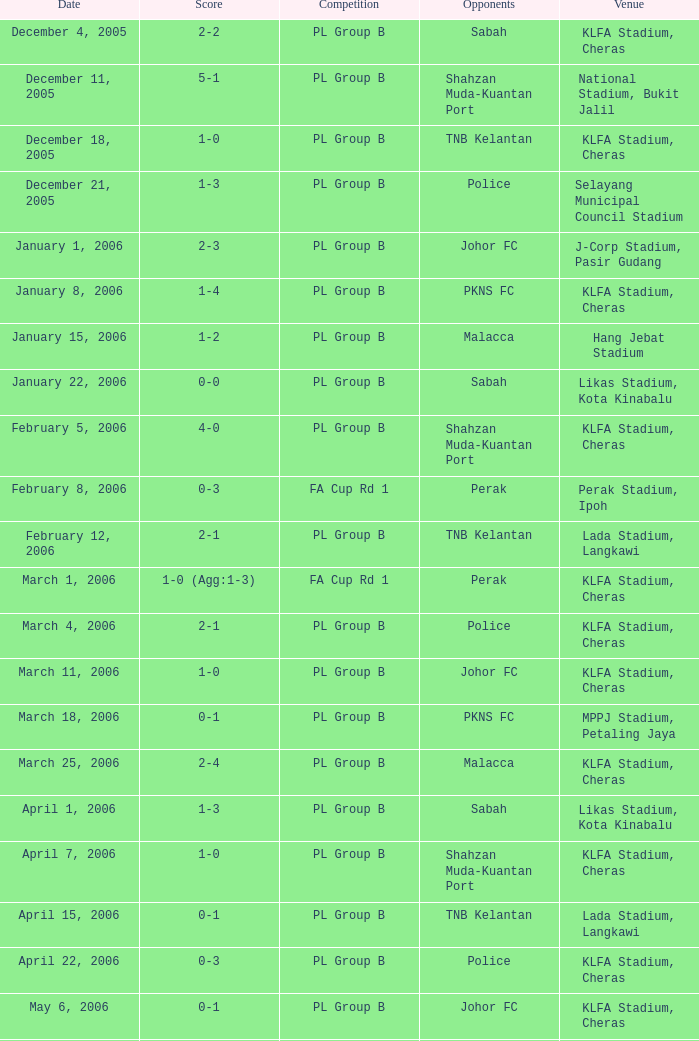Parse the table in full. {'header': ['Date', 'Score', 'Competition', 'Opponents', 'Venue'], 'rows': [['December 4, 2005', '2-2', 'PL Group B', 'Sabah', 'KLFA Stadium, Cheras'], ['December 11, 2005', '5-1', 'PL Group B', 'Shahzan Muda-Kuantan Port', 'National Stadium, Bukit Jalil'], ['December 18, 2005', '1-0', 'PL Group B', 'TNB Kelantan', 'KLFA Stadium, Cheras'], ['December 21, 2005', '1-3', 'PL Group B', 'Police', 'Selayang Municipal Council Stadium'], ['January 1, 2006', '2-3', 'PL Group B', 'Johor FC', 'J-Corp Stadium, Pasir Gudang'], ['January 8, 2006', '1-4', 'PL Group B', 'PKNS FC', 'KLFA Stadium, Cheras'], ['January 15, 2006', '1-2', 'PL Group B', 'Malacca', 'Hang Jebat Stadium'], ['January 22, 2006', '0-0', 'PL Group B', 'Sabah', 'Likas Stadium, Kota Kinabalu'], ['February 5, 2006', '4-0', 'PL Group B', 'Shahzan Muda-Kuantan Port', 'KLFA Stadium, Cheras'], ['February 8, 2006', '0-3', 'FA Cup Rd 1', 'Perak', 'Perak Stadium, Ipoh'], ['February 12, 2006', '2-1', 'PL Group B', 'TNB Kelantan', 'Lada Stadium, Langkawi'], ['March 1, 2006', '1-0 (Agg:1-3)', 'FA Cup Rd 1', 'Perak', 'KLFA Stadium, Cheras'], ['March 4, 2006', '2-1', 'PL Group B', 'Police', 'KLFA Stadium, Cheras'], ['March 11, 2006', '1-0', 'PL Group B', 'Johor FC', 'KLFA Stadium, Cheras'], ['March 18, 2006', '0-1', 'PL Group B', 'PKNS FC', 'MPPJ Stadium, Petaling Jaya'], ['March 25, 2006', '2-4', 'PL Group B', 'Malacca', 'KLFA Stadium, Cheras'], ['April 1, 2006', '1-3', 'PL Group B', 'Sabah', 'Likas Stadium, Kota Kinabalu'], ['April 7, 2006', '1-0', 'PL Group B', 'Shahzan Muda-Kuantan Port', 'KLFA Stadium, Cheras'], ['April 15, 2006', '0-1', 'PL Group B', 'TNB Kelantan', 'Lada Stadium, Langkawi'], ['April 22, 2006', '0-3', 'PL Group B', 'Police', 'KLFA Stadium, Cheras'], ['May 6, 2006', '0-1', 'PL Group B', 'Johor FC', 'KLFA Stadium, Cheras'], ['May 10, 2006', '0-0', 'PL Group B', 'PKNS FC', 'MPPJ Stadium, Petaling Jaya'], ['May 17, 2006', '2-1', 'PL Group B', 'Malacca', 'KLFA Stadium, Cheras']]} Which Competition has a Score of 0-1, and Opponents of pkns fc? PL Group B. 